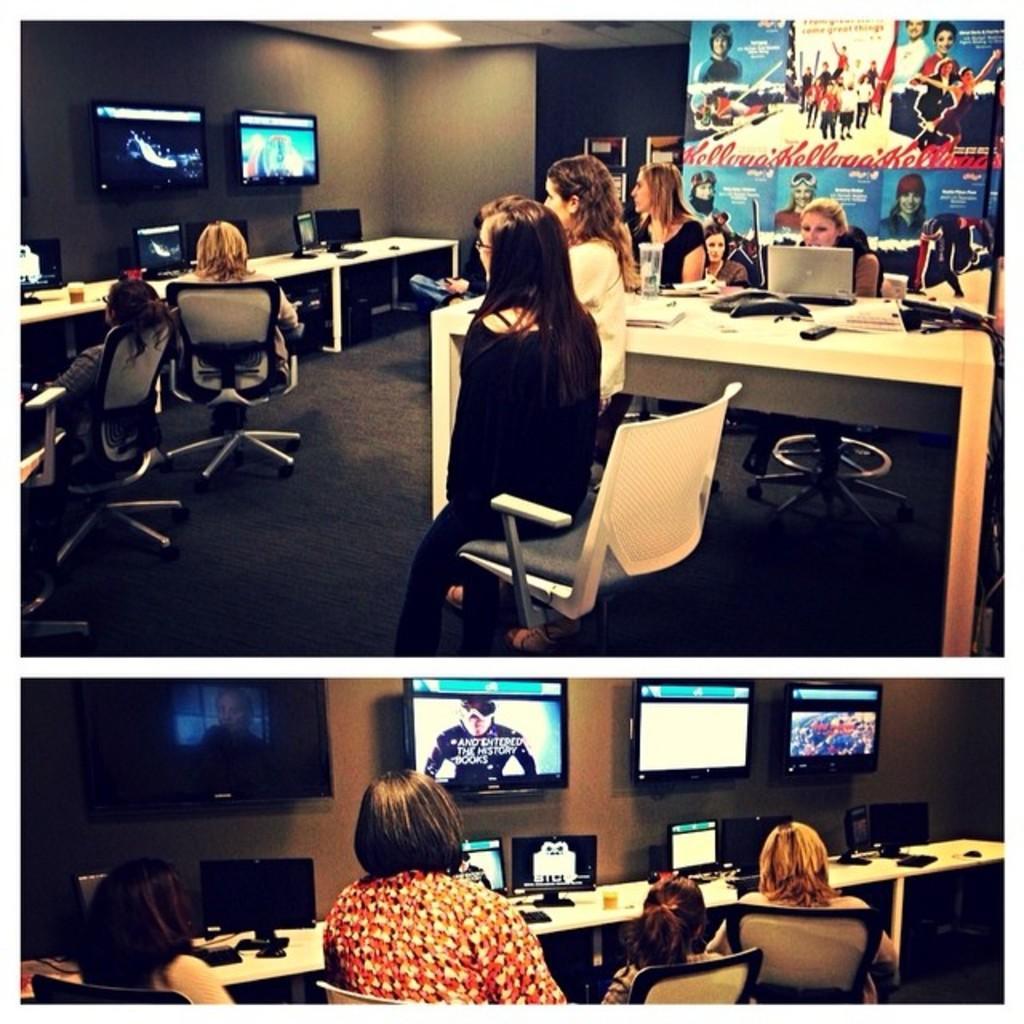Could you give a brief overview of what you see in this image? This is a collage of two images. In the first image there are some people in front of the tables in the chairs. There are two televisions attached to the wall in the background. In the second picture, there are some people watching three televisions attached to the wall, in front of a table on which some computers were placed. 